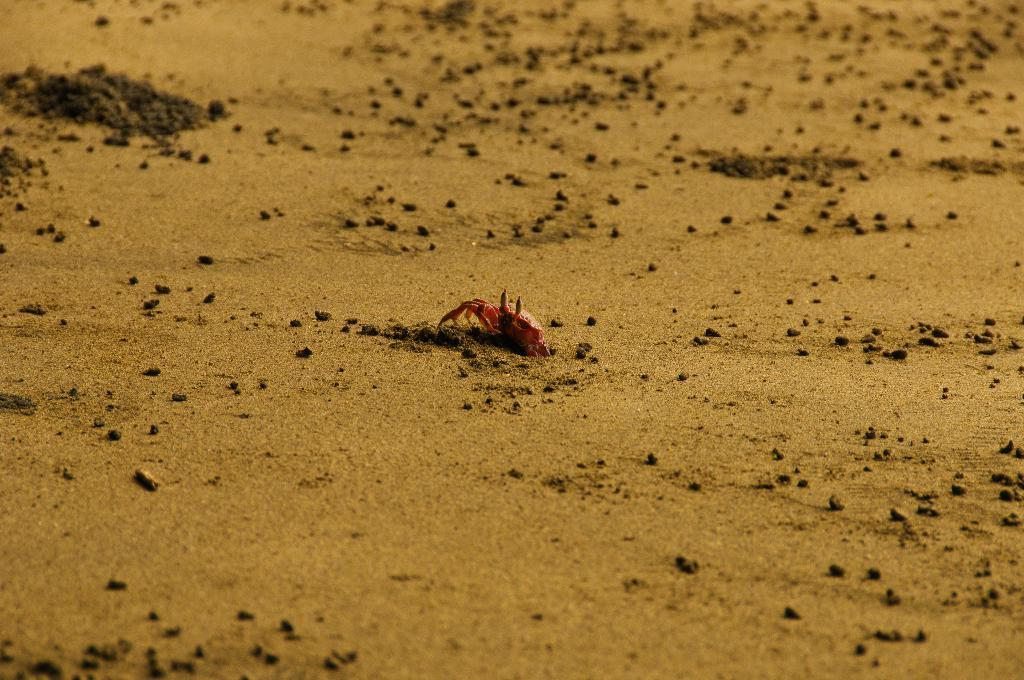What type of animal is in the image? There is a small red crab in the image. Where is the crab located? The crab is on the land. What is the crab's role in the digestion process in the image? There is no information about digestion in the image, as it only features a small red crab on the land. 